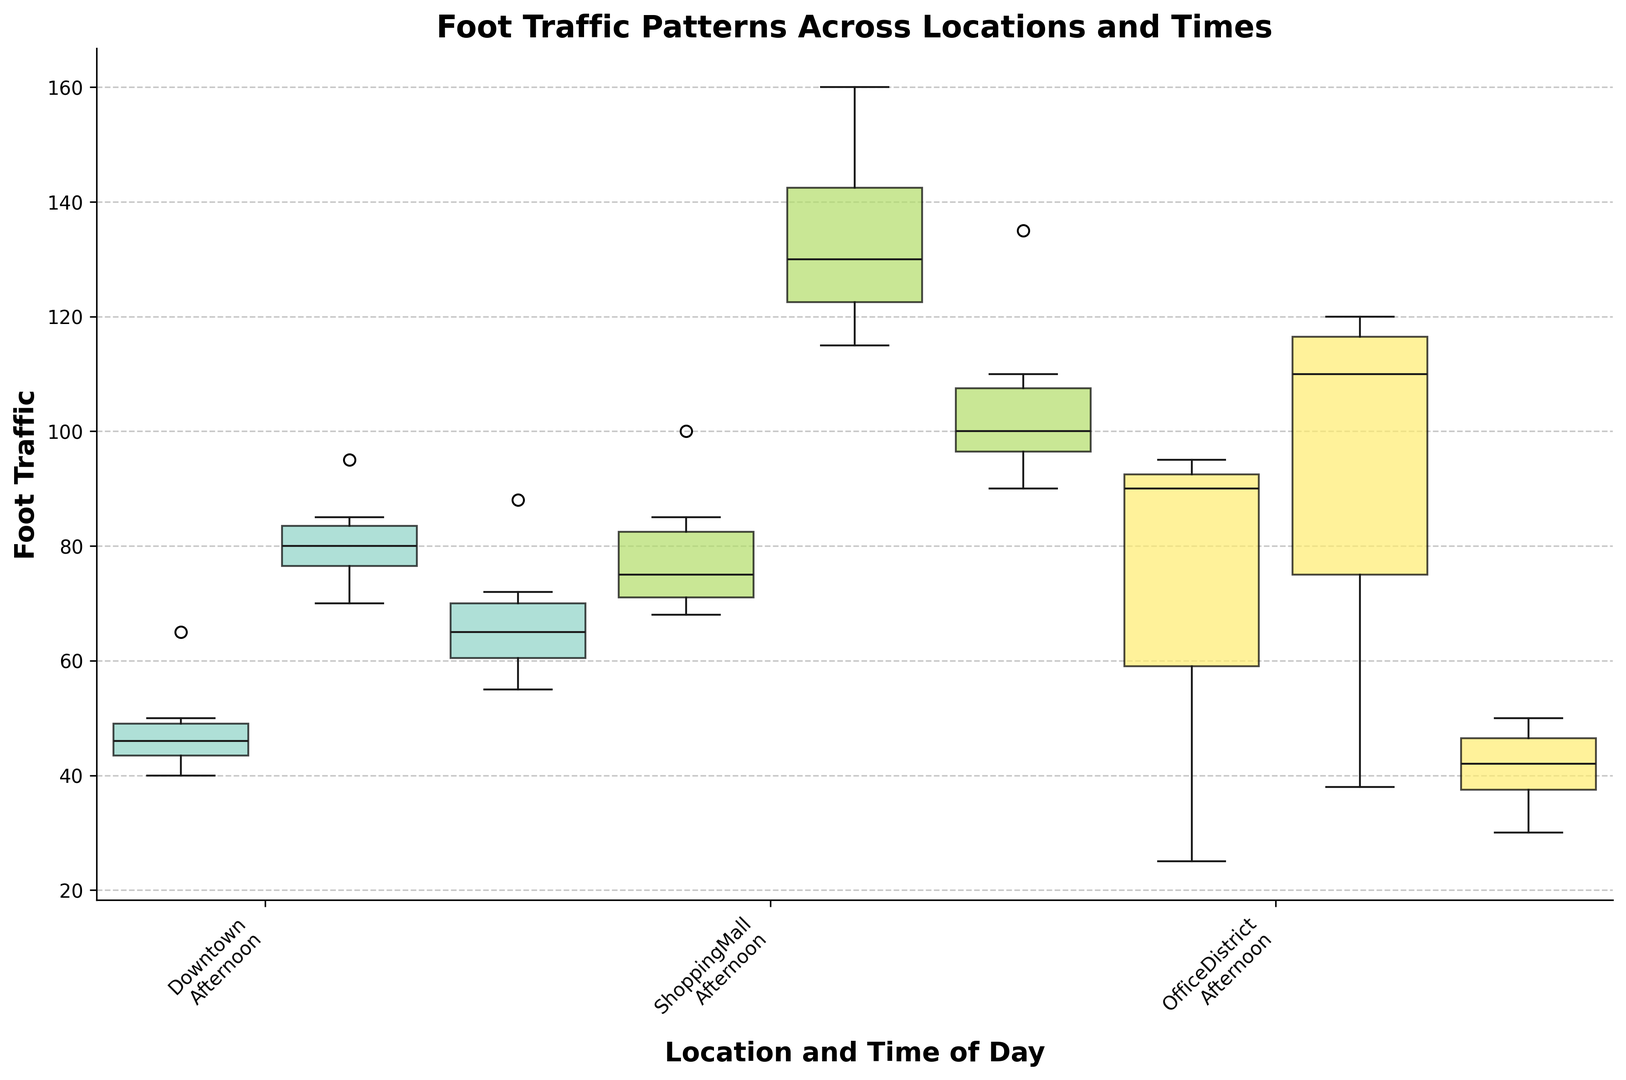Which location has the highest median foot traffic during the afternoon? Looking at the box plots for the afternoon time, compare the median lines (the center lines of the boxes). The ShoppingMall's box plot has the highest median line compared to Downtown and OfficeDistrict.
Answer: ShoppingMall Which time of day has the least foot traffic in the OfficeDistrict on average? For OfficeDistrict, observe the spread and position of the data in the box plots. Morning and afternoon have higher foot traffic and larger boxes, whereas evening exhibits smaller boxes and lower positions. Therefore, evening has the least foot traffic.
Answer: Evening By comparing the box plot color intensities, which location is shown in the brightest color and has the highest variation in foot traffic? Observe the colors used for each location. ShoppingMall uses the brightest color among the others. Its foot traffic variation (indicated by the box length) is the highest, especially in the Friday afternoon period.
Answer: ShoppingMall What is the median foot traffic at Downtown during the Sunday afternoon? Look at the box plot for Downtown on Sunday afternoon. The median line represents the median value, which corresponds to the middle line of that box.
Answer: 70 How does the foot traffic compare between downtown on a Saturday morning and a Friday afternoon? Compare the box positions and the height of Downtown's Saturday morning and Friday afternoon. The foot traffic is higher on a Friday afternoon than on a Saturday morning as indicated by the overall higher position and larger median value of the Friday afternoon box.
Answer: Friday afternoon has more foot traffic Which location sees the most consistent foot traffic, and how can you tell? Consistency in foot traffic is indicated by shorter box plots (less variation in the data). OfficeDistrict has the most uniform or least variable foot traffic measurements across different times of the day and week, demonstrated by the shorter box lengths.
Answer: OfficeDistrict When comparing weekdays, which day does Downtown experience peak foot traffic during the afternoon? Assess the height of the boxes representing afternoon foot traffic for each weekday at Downtown. The highest median line and position of the box occur on Friday, indicating peak foot traffic.
Answer: Friday What is the average foot traffic at ShoppingMall on weekends in the afternoon? First, identify the afternoon foot traffic values for Saturday and Sunday, which are 160 and 145. Calculate the average: (160 + 145) / 2 = 152.5
Answer: 152.5 